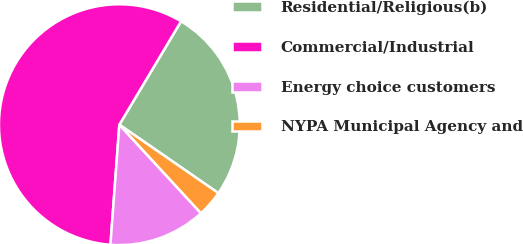<chart> <loc_0><loc_0><loc_500><loc_500><pie_chart><fcel>Residential/Religious(b)<fcel>Commercial/Industrial<fcel>Energy choice customers<fcel>NYPA Municipal Agency and<nl><fcel>26.06%<fcel>57.39%<fcel>13.03%<fcel>3.52%<nl></chart> 